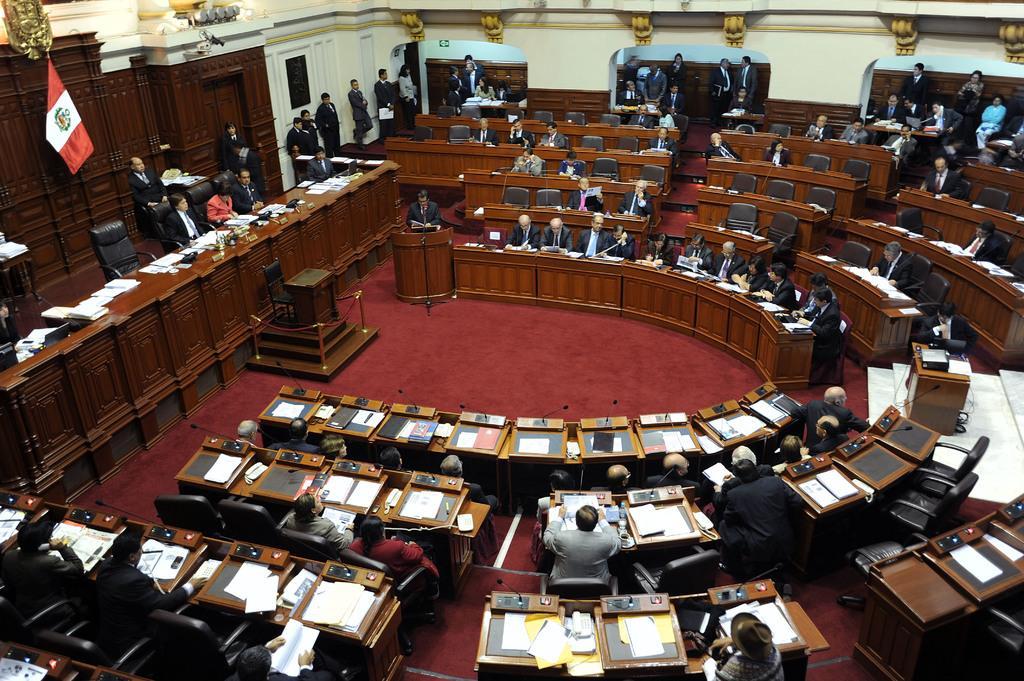Can you describe this image briefly? In this picture we can see a group of people some are sitting on chairs and some are standing at back and in front of them there is table and on table we can see papers, mics and in background we can see flag. 